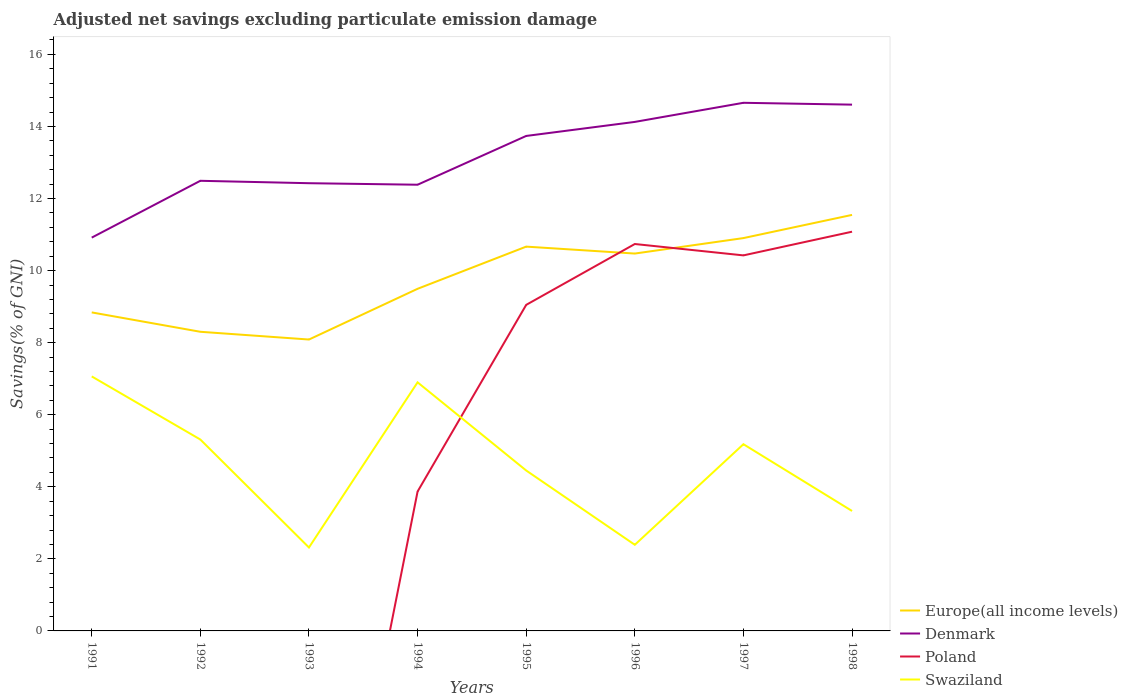Across all years, what is the maximum adjusted net savings in Denmark?
Provide a succinct answer. 10.92. What is the total adjusted net savings in Europe(all income levels) in the graph?
Offer a terse response. -1.19. What is the difference between the highest and the second highest adjusted net savings in Swaziland?
Give a very brief answer. 4.75. Is the adjusted net savings in Poland strictly greater than the adjusted net savings in Swaziland over the years?
Offer a terse response. No. How many years are there in the graph?
Provide a succinct answer. 8. Are the values on the major ticks of Y-axis written in scientific E-notation?
Provide a succinct answer. No. Does the graph contain any zero values?
Ensure brevity in your answer.  Yes. How many legend labels are there?
Offer a terse response. 4. How are the legend labels stacked?
Provide a short and direct response. Vertical. What is the title of the graph?
Give a very brief answer. Adjusted net savings excluding particulate emission damage. Does "Switzerland" appear as one of the legend labels in the graph?
Ensure brevity in your answer.  No. What is the label or title of the Y-axis?
Offer a terse response. Savings(% of GNI). What is the Savings(% of GNI) in Europe(all income levels) in 1991?
Your response must be concise. 8.84. What is the Savings(% of GNI) of Denmark in 1991?
Give a very brief answer. 10.92. What is the Savings(% of GNI) in Poland in 1991?
Your answer should be compact. 0. What is the Savings(% of GNI) in Swaziland in 1991?
Your answer should be very brief. 7.06. What is the Savings(% of GNI) of Europe(all income levels) in 1992?
Offer a very short reply. 8.3. What is the Savings(% of GNI) in Denmark in 1992?
Give a very brief answer. 12.49. What is the Savings(% of GNI) in Swaziland in 1992?
Offer a very short reply. 5.31. What is the Savings(% of GNI) of Europe(all income levels) in 1993?
Keep it short and to the point. 8.09. What is the Savings(% of GNI) of Denmark in 1993?
Your answer should be very brief. 12.43. What is the Savings(% of GNI) in Swaziland in 1993?
Your response must be concise. 2.32. What is the Savings(% of GNI) of Europe(all income levels) in 1994?
Offer a very short reply. 9.49. What is the Savings(% of GNI) of Denmark in 1994?
Your answer should be compact. 12.38. What is the Savings(% of GNI) in Poland in 1994?
Provide a short and direct response. 3.87. What is the Savings(% of GNI) of Swaziland in 1994?
Your answer should be very brief. 6.9. What is the Savings(% of GNI) of Europe(all income levels) in 1995?
Your response must be concise. 10.67. What is the Savings(% of GNI) of Denmark in 1995?
Provide a succinct answer. 13.74. What is the Savings(% of GNI) of Poland in 1995?
Your answer should be very brief. 9.05. What is the Savings(% of GNI) in Swaziland in 1995?
Make the answer very short. 4.45. What is the Savings(% of GNI) of Europe(all income levels) in 1996?
Your answer should be very brief. 10.47. What is the Savings(% of GNI) in Denmark in 1996?
Offer a very short reply. 14.13. What is the Savings(% of GNI) of Poland in 1996?
Ensure brevity in your answer.  10.74. What is the Savings(% of GNI) in Swaziland in 1996?
Offer a terse response. 2.39. What is the Savings(% of GNI) of Europe(all income levels) in 1997?
Provide a succinct answer. 10.9. What is the Savings(% of GNI) of Denmark in 1997?
Provide a short and direct response. 14.66. What is the Savings(% of GNI) in Poland in 1997?
Your answer should be very brief. 10.42. What is the Savings(% of GNI) of Swaziland in 1997?
Your answer should be compact. 5.18. What is the Savings(% of GNI) in Europe(all income levels) in 1998?
Ensure brevity in your answer.  11.55. What is the Savings(% of GNI) of Denmark in 1998?
Ensure brevity in your answer.  14.61. What is the Savings(% of GNI) in Poland in 1998?
Offer a very short reply. 11.08. What is the Savings(% of GNI) in Swaziland in 1998?
Provide a succinct answer. 3.33. Across all years, what is the maximum Savings(% of GNI) of Europe(all income levels)?
Give a very brief answer. 11.55. Across all years, what is the maximum Savings(% of GNI) in Denmark?
Offer a very short reply. 14.66. Across all years, what is the maximum Savings(% of GNI) of Poland?
Offer a terse response. 11.08. Across all years, what is the maximum Savings(% of GNI) of Swaziland?
Keep it short and to the point. 7.06. Across all years, what is the minimum Savings(% of GNI) in Europe(all income levels)?
Ensure brevity in your answer.  8.09. Across all years, what is the minimum Savings(% of GNI) of Denmark?
Offer a terse response. 10.92. Across all years, what is the minimum Savings(% of GNI) of Swaziland?
Provide a short and direct response. 2.32. What is the total Savings(% of GNI) in Europe(all income levels) in the graph?
Your answer should be very brief. 78.31. What is the total Savings(% of GNI) of Denmark in the graph?
Your answer should be compact. 105.34. What is the total Savings(% of GNI) of Poland in the graph?
Provide a short and direct response. 45.16. What is the total Savings(% of GNI) of Swaziland in the graph?
Provide a succinct answer. 36.94. What is the difference between the Savings(% of GNI) in Europe(all income levels) in 1991 and that in 1992?
Offer a very short reply. 0.54. What is the difference between the Savings(% of GNI) in Denmark in 1991 and that in 1992?
Offer a very short reply. -1.58. What is the difference between the Savings(% of GNI) of Swaziland in 1991 and that in 1992?
Make the answer very short. 1.75. What is the difference between the Savings(% of GNI) of Europe(all income levels) in 1991 and that in 1993?
Offer a very short reply. 0.75. What is the difference between the Savings(% of GNI) in Denmark in 1991 and that in 1993?
Your answer should be very brief. -1.51. What is the difference between the Savings(% of GNI) in Swaziland in 1991 and that in 1993?
Your answer should be very brief. 4.75. What is the difference between the Savings(% of GNI) of Europe(all income levels) in 1991 and that in 1994?
Your answer should be compact. -0.66. What is the difference between the Savings(% of GNI) of Denmark in 1991 and that in 1994?
Make the answer very short. -1.47. What is the difference between the Savings(% of GNI) of Swaziland in 1991 and that in 1994?
Provide a short and direct response. 0.16. What is the difference between the Savings(% of GNI) of Europe(all income levels) in 1991 and that in 1995?
Make the answer very short. -1.83. What is the difference between the Savings(% of GNI) in Denmark in 1991 and that in 1995?
Your answer should be compact. -2.82. What is the difference between the Savings(% of GNI) in Swaziland in 1991 and that in 1995?
Provide a short and direct response. 2.61. What is the difference between the Savings(% of GNI) in Europe(all income levels) in 1991 and that in 1996?
Offer a terse response. -1.63. What is the difference between the Savings(% of GNI) in Denmark in 1991 and that in 1996?
Your response must be concise. -3.21. What is the difference between the Savings(% of GNI) in Swaziland in 1991 and that in 1996?
Your response must be concise. 4.67. What is the difference between the Savings(% of GNI) in Europe(all income levels) in 1991 and that in 1997?
Make the answer very short. -2.06. What is the difference between the Savings(% of GNI) of Denmark in 1991 and that in 1997?
Keep it short and to the point. -3.74. What is the difference between the Savings(% of GNI) of Swaziland in 1991 and that in 1997?
Your response must be concise. 1.88. What is the difference between the Savings(% of GNI) of Europe(all income levels) in 1991 and that in 1998?
Provide a short and direct response. -2.71. What is the difference between the Savings(% of GNI) in Denmark in 1991 and that in 1998?
Offer a terse response. -3.69. What is the difference between the Savings(% of GNI) in Swaziland in 1991 and that in 1998?
Your response must be concise. 3.73. What is the difference between the Savings(% of GNI) in Europe(all income levels) in 1992 and that in 1993?
Offer a very short reply. 0.21. What is the difference between the Savings(% of GNI) in Denmark in 1992 and that in 1993?
Your response must be concise. 0.07. What is the difference between the Savings(% of GNI) in Swaziland in 1992 and that in 1993?
Your answer should be compact. 3. What is the difference between the Savings(% of GNI) in Europe(all income levels) in 1992 and that in 1994?
Offer a very short reply. -1.19. What is the difference between the Savings(% of GNI) of Denmark in 1992 and that in 1994?
Offer a very short reply. 0.11. What is the difference between the Savings(% of GNI) of Swaziland in 1992 and that in 1994?
Provide a succinct answer. -1.59. What is the difference between the Savings(% of GNI) in Europe(all income levels) in 1992 and that in 1995?
Give a very brief answer. -2.36. What is the difference between the Savings(% of GNI) in Denmark in 1992 and that in 1995?
Offer a terse response. -1.24. What is the difference between the Savings(% of GNI) in Swaziland in 1992 and that in 1995?
Offer a terse response. 0.86. What is the difference between the Savings(% of GNI) of Europe(all income levels) in 1992 and that in 1996?
Your response must be concise. -2.17. What is the difference between the Savings(% of GNI) in Denmark in 1992 and that in 1996?
Make the answer very short. -1.63. What is the difference between the Savings(% of GNI) in Swaziland in 1992 and that in 1996?
Make the answer very short. 2.92. What is the difference between the Savings(% of GNI) in Europe(all income levels) in 1992 and that in 1997?
Keep it short and to the point. -2.6. What is the difference between the Savings(% of GNI) in Denmark in 1992 and that in 1997?
Your answer should be compact. -2.16. What is the difference between the Savings(% of GNI) of Swaziland in 1992 and that in 1997?
Your response must be concise. 0.13. What is the difference between the Savings(% of GNI) of Europe(all income levels) in 1992 and that in 1998?
Offer a terse response. -3.24. What is the difference between the Savings(% of GNI) of Denmark in 1992 and that in 1998?
Give a very brief answer. -2.11. What is the difference between the Savings(% of GNI) in Swaziland in 1992 and that in 1998?
Offer a terse response. 1.98. What is the difference between the Savings(% of GNI) of Europe(all income levels) in 1993 and that in 1994?
Keep it short and to the point. -1.41. What is the difference between the Savings(% of GNI) of Denmark in 1993 and that in 1994?
Your answer should be compact. 0.04. What is the difference between the Savings(% of GNI) in Swaziland in 1993 and that in 1994?
Provide a succinct answer. -4.58. What is the difference between the Savings(% of GNI) in Europe(all income levels) in 1993 and that in 1995?
Your answer should be very brief. -2.58. What is the difference between the Savings(% of GNI) in Denmark in 1993 and that in 1995?
Your response must be concise. -1.31. What is the difference between the Savings(% of GNI) in Swaziland in 1993 and that in 1995?
Offer a terse response. -2.14. What is the difference between the Savings(% of GNI) in Europe(all income levels) in 1993 and that in 1996?
Offer a very short reply. -2.39. What is the difference between the Savings(% of GNI) of Denmark in 1993 and that in 1996?
Your answer should be very brief. -1.7. What is the difference between the Savings(% of GNI) in Swaziland in 1993 and that in 1996?
Ensure brevity in your answer.  -0.07. What is the difference between the Savings(% of GNI) in Europe(all income levels) in 1993 and that in 1997?
Ensure brevity in your answer.  -2.82. What is the difference between the Savings(% of GNI) in Denmark in 1993 and that in 1997?
Your answer should be very brief. -2.23. What is the difference between the Savings(% of GNI) of Swaziland in 1993 and that in 1997?
Give a very brief answer. -2.87. What is the difference between the Savings(% of GNI) in Europe(all income levels) in 1993 and that in 1998?
Give a very brief answer. -3.46. What is the difference between the Savings(% of GNI) in Denmark in 1993 and that in 1998?
Offer a terse response. -2.18. What is the difference between the Savings(% of GNI) of Swaziland in 1993 and that in 1998?
Your answer should be compact. -1.01. What is the difference between the Savings(% of GNI) in Europe(all income levels) in 1994 and that in 1995?
Your answer should be compact. -1.17. What is the difference between the Savings(% of GNI) of Denmark in 1994 and that in 1995?
Ensure brevity in your answer.  -1.35. What is the difference between the Savings(% of GNI) in Poland in 1994 and that in 1995?
Your response must be concise. -5.18. What is the difference between the Savings(% of GNI) of Swaziland in 1994 and that in 1995?
Ensure brevity in your answer.  2.45. What is the difference between the Savings(% of GNI) in Europe(all income levels) in 1994 and that in 1996?
Your answer should be very brief. -0.98. What is the difference between the Savings(% of GNI) of Denmark in 1994 and that in 1996?
Make the answer very short. -1.74. What is the difference between the Savings(% of GNI) of Poland in 1994 and that in 1996?
Your response must be concise. -6.87. What is the difference between the Savings(% of GNI) of Swaziland in 1994 and that in 1996?
Offer a very short reply. 4.51. What is the difference between the Savings(% of GNI) of Europe(all income levels) in 1994 and that in 1997?
Make the answer very short. -1.41. What is the difference between the Savings(% of GNI) of Denmark in 1994 and that in 1997?
Your answer should be very brief. -2.27. What is the difference between the Savings(% of GNI) in Poland in 1994 and that in 1997?
Give a very brief answer. -6.55. What is the difference between the Savings(% of GNI) of Swaziland in 1994 and that in 1997?
Provide a succinct answer. 1.72. What is the difference between the Savings(% of GNI) of Europe(all income levels) in 1994 and that in 1998?
Make the answer very short. -2.05. What is the difference between the Savings(% of GNI) of Denmark in 1994 and that in 1998?
Ensure brevity in your answer.  -2.22. What is the difference between the Savings(% of GNI) in Poland in 1994 and that in 1998?
Provide a short and direct response. -7.21. What is the difference between the Savings(% of GNI) of Swaziland in 1994 and that in 1998?
Make the answer very short. 3.57. What is the difference between the Savings(% of GNI) in Europe(all income levels) in 1995 and that in 1996?
Your response must be concise. 0.19. What is the difference between the Savings(% of GNI) in Denmark in 1995 and that in 1996?
Offer a very short reply. -0.39. What is the difference between the Savings(% of GNI) of Poland in 1995 and that in 1996?
Keep it short and to the point. -1.69. What is the difference between the Savings(% of GNI) in Swaziland in 1995 and that in 1996?
Ensure brevity in your answer.  2.06. What is the difference between the Savings(% of GNI) of Europe(all income levels) in 1995 and that in 1997?
Your answer should be compact. -0.24. What is the difference between the Savings(% of GNI) in Denmark in 1995 and that in 1997?
Ensure brevity in your answer.  -0.92. What is the difference between the Savings(% of GNI) in Poland in 1995 and that in 1997?
Provide a short and direct response. -1.37. What is the difference between the Savings(% of GNI) in Swaziland in 1995 and that in 1997?
Offer a terse response. -0.73. What is the difference between the Savings(% of GNI) of Europe(all income levels) in 1995 and that in 1998?
Offer a terse response. -0.88. What is the difference between the Savings(% of GNI) of Denmark in 1995 and that in 1998?
Ensure brevity in your answer.  -0.87. What is the difference between the Savings(% of GNI) of Poland in 1995 and that in 1998?
Offer a very short reply. -2.03. What is the difference between the Savings(% of GNI) in Swaziland in 1995 and that in 1998?
Ensure brevity in your answer.  1.12. What is the difference between the Savings(% of GNI) of Europe(all income levels) in 1996 and that in 1997?
Your answer should be compact. -0.43. What is the difference between the Savings(% of GNI) of Denmark in 1996 and that in 1997?
Your answer should be compact. -0.53. What is the difference between the Savings(% of GNI) in Poland in 1996 and that in 1997?
Provide a succinct answer. 0.32. What is the difference between the Savings(% of GNI) in Swaziland in 1996 and that in 1997?
Your answer should be very brief. -2.79. What is the difference between the Savings(% of GNI) of Europe(all income levels) in 1996 and that in 1998?
Your answer should be very brief. -1.07. What is the difference between the Savings(% of GNI) in Denmark in 1996 and that in 1998?
Keep it short and to the point. -0.48. What is the difference between the Savings(% of GNI) of Poland in 1996 and that in 1998?
Your answer should be compact. -0.34. What is the difference between the Savings(% of GNI) in Swaziland in 1996 and that in 1998?
Make the answer very short. -0.94. What is the difference between the Savings(% of GNI) in Europe(all income levels) in 1997 and that in 1998?
Offer a very short reply. -0.64. What is the difference between the Savings(% of GNI) of Denmark in 1997 and that in 1998?
Offer a very short reply. 0.05. What is the difference between the Savings(% of GNI) in Poland in 1997 and that in 1998?
Make the answer very short. -0.66. What is the difference between the Savings(% of GNI) of Swaziland in 1997 and that in 1998?
Your answer should be very brief. 1.85. What is the difference between the Savings(% of GNI) of Europe(all income levels) in 1991 and the Savings(% of GNI) of Denmark in 1992?
Make the answer very short. -3.65. What is the difference between the Savings(% of GNI) of Europe(all income levels) in 1991 and the Savings(% of GNI) of Swaziland in 1992?
Your answer should be very brief. 3.53. What is the difference between the Savings(% of GNI) in Denmark in 1991 and the Savings(% of GNI) in Swaziland in 1992?
Provide a succinct answer. 5.6. What is the difference between the Savings(% of GNI) of Europe(all income levels) in 1991 and the Savings(% of GNI) of Denmark in 1993?
Your answer should be very brief. -3.59. What is the difference between the Savings(% of GNI) of Europe(all income levels) in 1991 and the Savings(% of GNI) of Swaziland in 1993?
Offer a terse response. 6.52. What is the difference between the Savings(% of GNI) in Denmark in 1991 and the Savings(% of GNI) in Swaziland in 1993?
Provide a succinct answer. 8.6. What is the difference between the Savings(% of GNI) of Europe(all income levels) in 1991 and the Savings(% of GNI) of Denmark in 1994?
Provide a short and direct response. -3.54. What is the difference between the Savings(% of GNI) in Europe(all income levels) in 1991 and the Savings(% of GNI) in Poland in 1994?
Provide a succinct answer. 4.97. What is the difference between the Savings(% of GNI) in Europe(all income levels) in 1991 and the Savings(% of GNI) in Swaziland in 1994?
Ensure brevity in your answer.  1.94. What is the difference between the Savings(% of GNI) in Denmark in 1991 and the Savings(% of GNI) in Poland in 1994?
Keep it short and to the point. 7.05. What is the difference between the Savings(% of GNI) of Denmark in 1991 and the Savings(% of GNI) of Swaziland in 1994?
Ensure brevity in your answer.  4.02. What is the difference between the Savings(% of GNI) of Europe(all income levels) in 1991 and the Savings(% of GNI) of Denmark in 1995?
Provide a short and direct response. -4.9. What is the difference between the Savings(% of GNI) in Europe(all income levels) in 1991 and the Savings(% of GNI) in Poland in 1995?
Provide a short and direct response. -0.21. What is the difference between the Savings(% of GNI) of Europe(all income levels) in 1991 and the Savings(% of GNI) of Swaziland in 1995?
Your answer should be very brief. 4.39. What is the difference between the Savings(% of GNI) of Denmark in 1991 and the Savings(% of GNI) of Poland in 1995?
Give a very brief answer. 1.87. What is the difference between the Savings(% of GNI) in Denmark in 1991 and the Savings(% of GNI) in Swaziland in 1995?
Give a very brief answer. 6.46. What is the difference between the Savings(% of GNI) in Europe(all income levels) in 1991 and the Savings(% of GNI) in Denmark in 1996?
Provide a short and direct response. -5.29. What is the difference between the Savings(% of GNI) of Europe(all income levels) in 1991 and the Savings(% of GNI) of Poland in 1996?
Ensure brevity in your answer.  -1.9. What is the difference between the Savings(% of GNI) of Europe(all income levels) in 1991 and the Savings(% of GNI) of Swaziland in 1996?
Your answer should be very brief. 6.45. What is the difference between the Savings(% of GNI) of Denmark in 1991 and the Savings(% of GNI) of Poland in 1996?
Offer a very short reply. 0.18. What is the difference between the Savings(% of GNI) of Denmark in 1991 and the Savings(% of GNI) of Swaziland in 1996?
Your answer should be very brief. 8.52. What is the difference between the Savings(% of GNI) in Europe(all income levels) in 1991 and the Savings(% of GNI) in Denmark in 1997?
Ensure brevity in your answer.  -5.82. What is the difference between the Savings(% of GNI) of Europe(all income levels) in 1991 and the Savings(% of GNI) of Poland in 1997?
Make the answer very short. -1.58. What is the difference between the Savings(% of GNI) of Europe(all income levels) in 1991 and the Savings(% of GNI) of Swaziland in 1997?
Make the answer very short. 3.66. What is the difference between the Savings(% of GNI) in Denmark in 1991 and the Savings(% of GNI) in Poland in 1997?
Keep it short and to the point. 0.49. What is the difference between the Savings(% of GNI) of Denmark in 1991 and the Savings(% of GNI) of Swaziland in 1997?
Provide a succinct answer. 5.73. What is the difference between the Savings(% of GNI) of Europe(all income levels) in 1991 and the Savings(% of GNI) of Denmark in 1998?
Provide a succinct answer. -5.77. What is the difference between the Savings(% of GNI) of Europe(all income levels) in 1991 and the Savings(% of GNI) of Poland in 1998?
Your response must be concise. -2.24. What is the difference between the Savings(% of GNI) in Europe(all income levels) in 1991 and the Savings(% of GNI) in Swaziland in 1998?
Keep it short and to the point. 5.51. What is the difference between the Savings(% of GNI) of Denmark in 1991 and the Savings(% of GNI) of Poland in 1998?
Keep it short and to the point. -0.16. What is the difference between the Savings(% of GNI) in Denmark in 1991 and the Savings(% of GNI) in Swaziland in 1998?
Your answer should be compact. 7.59. What is the difference between the Savings(% of GNI) of Europe(all income levels) in 1992 and the Savings(% of GNI) of Denmark in 1993?
Keep it short and to the point. -4.12. What is the difference between the Savings(% of GNI) in Europe(all income levels) in 1992 and the Savings(% of GNI) in Swaziland in 1993?
Your response must be concise. 5.99. What is the difference between the Savings(% of GNI) of Denmark in 1992 and the Savings(% of GNI) of Swaziland in 1993?
Your response must be concise. 10.18. What is the difference between the Savings(% of GNI) in Europe(all income levels) in 1992 and the Savings(% of GNI) in Denmark in 1994?
Your answer should be very brief. -4.08. What is the difference between the Savings(% of GNI) in Europe(all income levels) in 1992 and the Savings(% of GNI) in Poland in 1994?
Your response must be concise. 4.43. What is the difference between the Savings(% of GNI) in Europe(all income levels) in 1992 and the Savings(% of GNI) in Swaziland in 1994?
Your response must be concise. 1.4. What is the difference between the Savings(% of GNI) of Denmark in 1992 and the Savings(% of GNI) of Poland in 1994?
Offer a terse response. 8.62. What is the difference between the Savings(% of GNI) in Denmark in 1992 and the Savings(% of GNI) in Swaziland in 1994?
Keep it short and to the point. 5.59. What is the difference between the Savings(% of GNI) in Europe(all income levels) in 1992 and the Savings(% of GNI) in Denmark in 1995?
Provide a succinct answer. -5.43. What is the difference between the Savings(% of GNI) of Europe(all income levels) in 1992 and the Savings(% of GNI) of Poland in 1995?
Provide a succinct answer. -0.75. What is the difference between the Savings(% of GNI) of Europe(all income levels) in 1992 and the Savings(% of GNI) of Swaziland in 1995?
Provide a succinct answer. 3.85. What is the difference between the Savings(% of GNI) of Denmark in 1992 and the Savings(% of GNI) of Poland in 1995?
Your answer should be compact. 3.44. What is the difference between the Savings(% of GNI) of Denmark in 1992 and the Savings(% of GNI) of Swaziland in 1995?
Make the answer very short. 8.04. What is the difference between the Savings(% of GNI) in Europe(all income levels) in 1992 and the Savings(% of GNI) in Denmark in 1996?
Provide a succinct answer. -5.82. What is the difference between the Savings(% of GNI) of Europe(all income levels) in 1992 and the Savings(% of GNI) of Poland in 1996?
Keep it short and to the point. -2.44. What is the difference between the Savings(% of GNI) in Europe(all income levels) in 1992 and the Savings(% of GNI) in Swaziland in 1996?
Ensure brevity in your answer.  5.91. What is the difference between the Savings(% of GNI) in Denmark in 1992 and the Savings(% of GNI) in Poland in 1996?
Your answer should be very brief. 1.75. What is the difference between the Savings(% of GNI) in Denmark in 1992 and the Savings(% of GNI) in Swaziland in 1996?
Provide a succinct answer. 10.1. What is the difference between the Savings(% of GNI) of Europe(all income levels) in 1992 and the Savings(% of GNI) of Denmark in 1997?
Give a very brief answer. -6.35. What is the difference between the Savings(% of GNI) in Europe(all income levels) in 1992 and the Savings(% of GNI) in Poland in 1997?
Your response must be concise. -2.12. What is the difference between the Savings(% of GNI) in Europe(all income levels) in 1992 and the Savings(% of GNI) in Swaziland in 1997?
Provide a succinct answer. 3.12. What is the difference between the Savings(% of GNI) of Denmark in 1992 and the Savings(% of GNI) of Poland in 1997?
Make the answer very short. 2.07. What is the difference between the Savings(% of GNI) in Denmark in 1992 and the Savings(% of GNI) in Swaziland in 1997?
Keep it short and to the point. 7.31. What is the difference between the Savings(% of GNI) of Europe(all income levels) in 1992 and the Savings(% of GNI) of Denmark in 1998?
Make the answer very short. -6.3. What is the difference between the Savings(% of GNI) in Europe(all income levels) in 1992 and the Savings(% of GNI) in Poland in 1998?
Your answer should be very brief. -2.78. What is the difference between the Savings(% of GNI) in Europe(all income levels) in 1992 and the Savings(% of GNI) in Swaziland in 1998?
Provide a short and direct response. 4.97. What is the difference between the Savings(% of GNI) of Denmark in 1992 and the Savings(% of GNI) of Poland in 1998?
Provide a succinct answer. 1.41. What is the difference between the Savings(% of GNI) in Denmark in 1992 and the Savings(% of GNI) in Swaziland in 1998?
Provide a succinct answer. 9.16. What is the difference between the Savings(% of GNI) in Europe(all income levels) in 1993 and the Savings(% of GNI) in Denmark in 1994?
Provide a short and direct response. -4.3. What is the difference between the Savings(% of GNI) of Europe(all income levels) in 1993 and the Savings(% of GNI) of Poland in 1994?
Provide a short and direct response. 4.22. What is the difference between the Savings(% of GNI) in Europe(all income levels) in 1993 and the Savings(% of GNI) in Swaziland in 1994?
Your answer should be compact. 1.19. What is the difference between the Savings(% of GNI) in Denmark in 1993 and the Savings(% of GNI) in Poland in 1994?
Provide a succinct answer. 8.56. What is the difference between the Savings(% of GNI) in Denmark in 1993 and the Savings(% of GNI) in Swaziland in 1994?
Give a very brief answer. 5.53. What is the difference between the Savings(% of GNI) of Europe(all income levels) in 1993 and the Savings(% of GNI) of Denmark in 1995?
Provide a short and direct response. -5.65. What is the difference between the Savings(% of GNI) of Europe(all income levels) in 1993 and the Savings(% of GNI) of Poland in 1995?
Offer a terse response. -0.96. What is the difference between the Savings(% of GNI) of Europe(all income levels) in 1993 and the Savings(% of GNI) of Swaziland in 1995?
Your answer should be very brief. 3.63. What is the difference between the Savings(% of GNI) in Denmark in 1993 and the Savings(% of GNI) in Poland in 1995?
Offer a terse response. 3.38. What is the difference between the Savings(% of GNI) of Denmark in 1993 and the Savings(% of GNI) of Swaziland in 1995?
Your answer should be very brief. 7.97. What is the difference between the Savings(% of GNI) in Europe(all income levels) in 1993 and the Savings(% of GNI) in Denmark in 1996?
Provide a short and direct response. -6.04. What is the difference between the Savings(% of GNI) in Europe(all income levels) in 1993 and the Savings(% of GNI) in Poland in 1996?
Offer a terse response. -2.65. What is the difference between the Savings(% of GNI) in Europe(all income levels) in 1993 and the Savings(% of GNI) in Swaziland in 1996?
Keep it short and to the point. 5.7. What is the difference between the Savings(% of GNI) in Denmark in 1993 and the Savings(% of GNI) in Poland in 1996?
Keep it short and to the point. 1.69. What is the difference between the Savings(% of GNI) in Denmark in 1993 and the Savings(% of GNI) in Swaziland in 1996?
Offer a terse response. 10.03. What is the difference between the Savings(% of GNI) of Europe(all income levels) in 1993 and the Savings(% of GNI) of Denmark in 1997?
Your answer should be very brief. -6.57. What is the difference between the Savings(% of GNI) in Europe(all income levels) in 1993 and the Savings(% of GNI) in Poland in 1997?
Your response must be concise. -2.34. What is the difference between the Savings(% of GNI) in Europe(all income levels) in 1993 and the Savings(% of GNI) in Swaziland in 1997?
Ensure brevity in your answer.  2.91. What is the difference between the Savings(% of GNI) of Denmark in 1993 and the Savings(% of GNI) of Poland in 1997?
Provide a short and direct response. 2. What is the difference between the Savings(% of GNI) of Denmark in 1993 and the Savings(% of GNI) of Swaziland in 1997?
Your answer should be very brief. 7.24. What is the difference between the Savings(% of GNI) in Europe(all income levels) in 1993 and the Savings(% of GNI) in Denmark in 1998?
Your answer should be very brief. -6.52. What is the difference between the Savings(% of GNI) of Europe(all income levels) in 1993 and the Savings(% of GNI) of Poland in 1998?
Your answer should be compact. -2.99. What is the difference between the Savings(% of GNI) of Europe(all income levels) in 1993 and the Savings(% of GNI) of Swaziland in 1998?
Make the answer very short. 4.76. What is the difference between the Savings(% of GNI) of Denmark in 1993 and the Savings(% of GNI) of Poland in 1998?
Give a very brief answer. 1.35. What is the difference between the Savings(% of GNI) of Denmark in 1993 and the Savings(% of GNI) of Swaziland in 1998?
Ensure brevity in your answer.  9.1. What is the difference between the Savings(% of GNI) in Europe(all income levels) in 1994 and the Savings(% of GNI) in Denmark in 1995?
Give a very brief answer. -4.24. What is the difference between the Savings(% of GNI) in Europe(all income levels) in 1994 and the Savings(% of GNI) in Poland in 1995?
Provide a succinct answer. 0.45. What is the difference between the Savings(% of GNI) of Europe(all income levels) in 1994 and the Savings(% of GNI) of Swaziland in 1995?
Provide a succinct answer. 5.04. What is the difference between the Savings(% of GNI) of Denmark in 1994 and the Savings(% of GNI) of Poland in 1995?
Give a very brief answer. 3.33. What is the difference between the Savings(% of GNI) in Denmark in 1994 and the Savings(% of GNI) in Swaziland in 1995?
Provide a succinct answer. 7.93. What is the difference between the Savings(% of GNI) of Poland in 1994 and the Savings(% of GNI) of Swaziland in 1995?
Provide a succinct answer. -0.58. What is the difference between the Savings(% of GNI) of Europe(all income levels) in 1994 and the Savings(% of GNI) of Denmark in 1996?
Keep it short and to the point. -4.63. What is the difference between the Savings(% of GNI) in Europe(all income levels) in 1994 and the Savings(% of GNI) in Poland in 1996?
Your answer should be very brief. -1.24. What is the difference between the Savings(% of GNI) of Europe(all income levels) in 1994 and the Savings(% of GNI) of Swaziland in 1996?
Offer a very short reply. 7.1. What is the difference between the Savings(% of GNI) in Denmark in 1994 and the Savings(% of GNI) in Poland in 1996?
Your answer should be very brief. 1.65. What is the difference between the Savings(% of GNI) of Denmark in 1994 and the Savings(% of GNI) of Swaziland in 1996?
Offer a terse response. 9.99. What is the difference between the Savings(% of GNI) of Poland in 1994 and the Savings(% of GNI) of Swaziland in 1996?
Ensure brevity in your answer.  1.48. What is the difference between the Savings(% of GNI) in Europe(all income levels) in 1994 and the Savings(% of GNI) in Denmark in 1997?
Give a very brief answer. -5.16. What is the difference between the Savings(% of GNI) in Europe(all income levels) in 1994 and the Savings(% of GNI) in Poland in 1997?
Your answer should be compact. -0.93. What is the difference between the Savings(% of GNI) in Europe(all income levels) in 1994 and the Savings(% of GNI) in Swaziland in 1997?
Keep it short and to the point. 4.31. What is the difference between the Savings(% of GNI) in Denmark in 1994 and the Savings(% of GNI) in Poland in 1997?
Offer a very short reply. 1.96. What is the difference between the Savings(% of GNI) of Denmark in 1994 and the Savings(% of GNI) of Swaziland in 1997?
Keep it short and to the point. 7.2. What is the difference between the Savings(% of GNI) in Poland in 1994 and the Savings(% of GNI) in Swaziland in 1997?
Your answer should be very brief. -1.31. What is the difference between the Savings(% of GNI) in Europe(all income levels) in 1994 and the Savings(% of GNI) in Denmark in 1998?
Ensure brevity in your answer.  -5.11. What is the difference between the Savings(% of GNI) in Europe(all income levels) in 1994 and the Savings(% of GNI) in Poland in 1998?
Give a very brief answer. -1.58. What is the difference between the Savings(% of GNI) of Europe(all income levels) in 1994 and the Savings(% of GNI) of Swaziland in 1998?
Offer a terse response. 6.17. What is the difference between the Savings(% of GNI) in Denmark in 1994 and the Savings(% of GNI) in Poland in 1998?
Provide a succinct answer. 1.3. What is the difference between the Savings(% of GNI) in Denmark in 1994 and the Savings(% of GNI) in Swaziland in 1998?
Offer a terse response. 9.05. What is the difference between the Savings(% of GNI) of Poland in 1994 and the Savings(% of GNI) of Swaziland in 1998?
Your answer should be very brief. 0.54. What is the difference between the Savings(% of GNI) of Europe(all income levels) in 1995 and the Savings(% of GNI) of Denmark in 1996?
Give a very brief answer. -3.46. What is the difference between the Savings(% of GNI) in Europe(all income levels) in 1995 and the Savings(% of GNI) in Poland in 1996?
Your answer should be compact. -0.07. What is the difference between the Savings(% of GNI) of Europe(all income levels) in 1995 and the Savings(% of GNI) of Swaziland in 1996?
Offer a terse response. 8.27. What is the difference between the Savings(% of GNI) of Denmark in 1995 and the Savings(% of GNI) of Poland in 1996?
Your response must be concise. 3. What is the difference between the Savings(% of GNI) of Denmark in 1995 and the Savings(% of GNI) of Swaziland in 1996?
Your response must be concise. 11.35. What is the difference between the Savings(% of GNI) in Poland in 1995 and the Savings(% of GNI) in Swaziland in 1996?
Offer a terse response. 6.66. What is the difference between the Savings(% of GNI) of Europe(all income levels) in 1995 and the Savings(% of GNI) of Denmark in 1997?
Provide a succinct answer. -3.99. What is the difference between the Savings(% of GNI) in Europe(all income levels) in 1995 and the Savings(% of GNI) in Poland in 1997?
Provide a short and direct response. 0.24. What is the difference between the Savings(% of GNI) in Europe(all income levels) in 1995 and the Savings(% of GNI) in Swaziland in 1997?
Ensure brevity in your answer.  5.48. What is the difference between the Savings(% of GNI) in Denmark in 1995 and the Savings(% of GNI) in Poland in 1997?
Your answer should be compact. 3.31. What is the difference between the Savings(% of GNI) of Denmark in 1995 and the Savings(% of GNI) of Swaziland in 1997?
Provide a short and direct response. 8.56. What is the difference between the Savings(% of GNI) in Poland in 1995 and the Savings(% of GNI) in Swaziland in 1997?
Offer a terse response. 3.87. What is the difference between the Savings(% of GNI) in Europe(all income levels) in 1995 and the Savings(% of GNI) in Denmark in 1998?
Provide a short and direct response. -3.94. What is the difference between the Savings(% of GNI) of Europe(all income levels) in 1995 and the Savings(% of GNI) of Poland in 1998?
Provide a short and direct response. -0.41. What is the difference between the Savings(% of GNI) in Europe(all income levels) in 1995 and the Savings(% of GNI) in Swaziland in 1998?
Your answer should be compact. 7.34. What is the difference between the Savings(% of GNI) of Denmark in 1995 and the Savings(% of GNI) of Poland in 1998?
Your answer should be compact. 2.66. What is the difference between the Savings(% of GNI) in Denmark in 1995 and the Savings(% of GNI) in Swaziland in 1998?
Offer a very short reply. 10.41. What is the difference between the Savings(% of GNI) of Poland in 1995 and the Savings(% of GNI) of Swaziland in 1998?
Provide a succinct answer. 5.72. What is the difference between the Savings(% of GNI) of Europe(all income levels) in 1996 and the Savings(% of GNI) of Denmark in 1997?
Give a very brief answer. -4.18. What is the difference between the Savings(% of GNI) of Europe(all income levels) in 1996 and the Savings(% of GNI) of Poland in 1997?
Offer a terse response. 0.05. What is the difference between the Savings(% of GNI) of Europe(all income levels) in 1996 and the Savings(% of GNI) of Swaziland in 1997?
Offer a terse response. 5.29. What is the difference between the Savings(% of GNI) in Denmark in 1996 and the Savings(% of GNI) in Poland in 1997?
Offer a terse response. 3.7. What is the difference between the Savings(% of GNI) in Denmark in 1996 and the Savings(% of GNI) in Swaziland in 1997?
Ensure brevity in your answer.  8.94. What is the difference between the Savings(% of GNI) of Poland in 1996 and the Savings(% of GNI) of Swaziland in 1997?
Keep it short and to the point. 5.56. What is the difference between the Savings(% of GNI) of Europe(all income levels) in 1996 and the Savings(% of GNI) of Denmark in 1998?
Your response must be concise. -4.13. What is the difference between the Savings(% of GNI) in Europe(all income levels) in 1996 and the Savings(% of GNI) in Poland in 1998?
Make the answer very short. -0.61. What is the difference between the Savings(% of GNI) in Europe(all income levels) in 1996 and the Savings(% of GNI) in Swaziland in 1998?
Offer a very short reply. 7.14. What is the difference between the Savings(% of GNI) in Denmark in 1996 and the Savings(% of GNI) in Poland in 1998?
Keep it short and to the point. 3.05. What is the difference between the Savings(% of GNI) of Denmark in 1996 and the Savings(% of GNI) of Swaziland in 1998?
Your answer should be compact. 10.8. What is the difference between the Savings(% of GNI) of Poland in 1996 and the Savings(% of GNI) of Swaziland in 1998?
Ensure brevity in your answer.  7.41. What is the difference between the Savings(% of GNI) of Europe(all income levels) in 1997 and the Savings(% of GNI) of Denmark in 1998?
Provide a short and direct response. -3.7. What is the difference between the Savings(% of GNI) in Europe(all income levels) in 1997 and the Savings(% of GNI) in Poland in 1998?
Offer a very short reply. -0.18. What is the difference between the Savings(% of GNI) in Europe(all income levels) in 1997 and the Savings(% of GNI) in Swaziland in 1998?
Make the answer very short. 7.57. What is the difference between the Savings(% of GNI) in Denmark in 1997 and the Savings(% of GNI) in Poland in 1998?
Give a very brief answer. 3.58. What is the difference between the Savings(% of GNI) in Denmark in 1997 and the Savings(% of GNI) in Swaziland in 1998?
Offer a terse response. 11.33. What is the difference between the Savings(% of GNI) in Poland in 1997 and the Savings(% of GNI) in Swaziland in 1998?
Offer a terse response. 7.09. What is the average Savings(% of GNI) in Europe(all income levels) per year?
Make the answer very short. 9.79. What is the average Savings(% of GNI) in Denmark per year?
Your response must be concise. 13.17. What is the average Savings(% of GNI) of Poland per year?
Ensure brevity in your answer.  5.64. What is the average Savings(% of GNI) in Swaziland per year?
Keep it short and to the point. 4.62. In the year 1991, what is the difference between the Savings(% of GNI) in Europe(all income levels) and Savings(% of GNI) in Denmark?
Offer a terse response. -2.08. In the year 1991, what is the difference between the Savings(% of GNI) in Europe(all income levels) and Savings(% of GNI) in Swaziland?
Give a very brief answer. 1.78. In the year 1991, what is the difference between the Savings(% of GNI) of Denmark and Savings(% of GNI) of Swaziland?
Your response must be concise. 3.85. In the year 1992, what is the difference between the Savings(% of GNI) in Europe(all income levels) and Savings(% of GNI) in Denmark?
Offer a terse response. -4.19. In the year 1992, what is the difference between the Savings(% of GNI) of Europe(all income levels) and Savings(% of GNI) of Swaziland?
Your response must be concise. 2.99. In the year 1992, what is the difference between the Savings(% of GNI) in Denmark and Savings(% of GNI) in Swaziland?
Provide a short and direct response. 7.18. In the year 1993, what is the difference between the Savings(% of GNI) of Europe(all income levels) and Savings(% of GNI) of Denmark?
Provide a succinct answer. -4.34. In the year 1993, what is the difference between the Savings(% of GNI) in Europe(all income levels) and Savings(% of GNI) in Swaziland?
Your response must be concise. 5.77. In the year 1993, what is the difference between the Savings(% of GNI) in Denmark and Savings(% of GNI) in Swaziland?
Provide a short and direct response. 10.11. In the year 1994, what is the difference between the Savings(% of GNI) in Europe(all income levels) and Savings(% of GNI) in Denmark?
Your answer should be very brief. -2.89. In the year 1994, what is the difference between the Savings(% of GNI) in Europe(all income levels) and Savings(% of GNI) in Poland?
Make the answer very short. 5.63. In the year 1994, what is the difference between the Savings(% of GNI) in Europe(all income levels) and Savings(% of GNI) in Swaziland?
Make the answer very short. 2.6. In the year 1994, what is the difference between the Savings(% of GNI) of Denmark and Savings(% of GNI) of Poland?
Offer a very short reply. 8.51. In the year 1994, what is the difference between the Savings(% of GNI) in Denmark and Savings(% of GNI) in Swaziland?
Provide a short and direct response. 5.48. In the year 1994, what is the difference between the Savings(% of GNI) in Poland and Savings(% of GNI) in Swaziland?
Keep it short and to the point. -3.03. In the year 1995, what is the difference between the Savings(% of GNI) in Europe(all income levels) and Savings(% of GNI) in Denmark?
Give a very brief answer. -3.07. In the year 1995, what is the difference between the Savings(% of GNI) of Europe(all income levels) and Savings(% of GNI) of Poland?
Provide a short and direct response. 1.62. In the year 1995, what is the difference between the Savings(% of GNI) of Europe(all income levels) and Savings(% of GNI) of Swaziland?
Your response must be concise. 6.21. In the year 1995, what is the difference between the Savings(% of GNI) of Denmark and Savings(% of GNI) of Poland?
Make the answer very short. 4.69. In the year 1995, what is the difference between the Savings(% of GNI) of Denmark and Savings(% of GNI) of Swaziland?
Offer a terse response. 9.28. In the year 1995, what is the difference between the Savings(% of GNI) in Poland and Savings(% of GNI) in Swaziland?
Your answer should be compact. 4.6. In the year 1996, what is the difference between the Savings(% of GNI) of Europe(all income levels) and Savings(% of GNI) of Denmark?
Give a very brief answer. -3.65. In the year 1996, what is the difference between the Savings(% of GNI) of Europe(all income levels) and Savings(% of GNI) of Poland?
Provide a succinct answer. -0.26. In the year 1996, what is the difference between the Savings(% of GNI) of Europe(all income levels) and Savings(% of GNI) of Swaziland?
Offer a very short reply. 8.08. In the year 1996, what is the difference between the Savings(% of GNI) in Denmark and Savings(% of GNI) in Poland?
Make the answer very short. 3.39. In the year 1996, what is the difference between the Savings(% of GNI) of Denmark and Savings(% of GNI) of Swaziland?
Your answer should be compact. 11.74. In the year 1996, what is the difference between the Savings(% of GNI) in Poland and Savings(% of GNI) in Swaziland?
Offer a terse response. 8.35. In the year 1997, what is the difference between the Savings(% of GNI) in Europe(all income levels) and Savings(% of GNI) in Denmark?
Your answer should be compact. -3.75. In the year 1997, what is the difference between the Savings(% of GNI) of Europe(all income levels) and Savings(% of GNI) of Poland?
Provide a succinct answer. 0.48. In the year 1997, what is the difference between the Savings(% of GNI) in Europe(all income levels) and Savings(% of GNI) in Swaziland?
Ensure brevity in your answer.  5.72. In the year 1997, what is the difference between the Savings(% of GNI) in Denmark and Savings(% of GNI) in Poland?
Your answer should be very brief. 4.23. In the year 1997, what is the difference between the Savings(% of GNI) of Denmark and Savings(% of GNI) of Swaziland?
Give a very brief answer. 9.47. In the year 1997, what is the difference between the Savings(% of GNI) of Poland and Savings(% of GNI) of Swaziland?
Your answer should be very brief. 5.24. In the year 1998, what is the difference between the Savings(% of GNI) of Europe(all income levels) and Savings(% of GNI) of Denmark?
Your answer should be compact. -3.06. In the year 1998, what is the difference between the Savings(% of GNI) in Europe(all income levels) and Savings(% of GNI) in Poland?
Give a very brief answer. 0.47. In the year 1998, what is the difference between the Savings(% of GNI) in Europe(all income levels) and Savings(% of GNI) in Swaziland?
Keep it short and to the point. 8.22. In the year 1998, what is the difference between the Savings(% of GNI) of Denmark and Savings(% of GNI) of Poland?
Offer a very short reply. 3.53. In the year 1998, what is the difference between the Savings(% of GNI) in Denmark and Savings(% of GNI) in Swaziland?
Ensure brevity in your answer.  11.28. In the year 1998, what is the difference between the Savings(% of GNI) of Poland and Savings(% of GNI) of Swaziland?
Give a very brief answer. 7.75. What is the ratio of the Savings(% of GNI) of Europe(all income levels) in 1991 to that in 1992?
Provide a succinct answer. 1.06. What is the ratio of the Savings(% of GNI) in Denmark in 1991 to that in 1992?
Provide a short and direct response. 0.87. What is the ratio of the Savings(% of GNI) in Swaziland in 1991 to that in 1992?
Provide a short and direct response. 1.33. What is the ratio of the Savings(% of GNI) of Europe(all income levels) in 1991 to that in 1993?
Your answer should be very brief. 1.09. What is the ratio of the Savings(% of GNI) in Denmark in 1991 to that in 1993?
Keep it short and to the point. 0.88. What is the ratio of the Savings(% of GNI) of Swaziland in 1991 to that in 1993?
Your answer should be very brief. 3.05. What is the ratio of the Savings(% of GNI) of Denmark in 1991 to that in 1994?
Provide a succinct answer. 0.88. What is the ratio of the Savings(% of GNI) in Swaziland in 1991 to that in 1994?
Make the answer very short. 1.02. What is the ratio of the Savings(% of GNI) of Europe(all income levels) in 1991 to that in 1995?
Your response must be concise. 0.83. What is the ratio of the Savings(% of GNI) of Denmark in 1991 to that in 1995?
Offer a very short reply. 0.79. What is the ratio of the Savings(% of GNI) of Swaziland in 1991 to that in 1995?
Make the answer very short. 1.59. What is the ratio of the Savings(% of GNI) in Europe(all income levels) in 1991 to that in 1996?
Provide a succinct answer. 0.84. What is the ratio of the Savings(% of GNI) in Denmark in 1991 to that in 1996?
Give a very brief answer. 0.77. What is the ratio of the Savings(% of GNI) in Swaziland in 1991 to that in 1996?
Make the answer very short. 2.95. What is the ratio of the Savings(% of GNI) in Europe(all income levels) in 1991 to that in 1997?
Provide a succinct answer. 0.81. What is the ratio of the Savings(% of GNI) in Denmark in 1991 to that in 1997?
Give a very brief answer. 0.74. What is the ratio of the Savings(% of GNI) in Swaziland in 1991 to that in 1997?
Provide a succinct answer. 1.36. What is the ratio of the Savings(% of GNI) of Europe(all income levels) in 1991 to that in 1998?
Offer a terse response. 0.77. What is the ratio of the Savings(% of GNI) in Denmark in 1991 to that in 1998?
Keep it short and to the point. 0.75. What is the ratio of the Savings(% of GNI) of Swaziland in 1991 to that in 1998?
Provide a succinct answer. 2.12. What is the ratio of the Savings(% of GNI) of Europe(all income levels) in 1992 to that in 1993?
Ensure brevity in your answer.  1.03. What is the ratio of the Savings(% of GNI) in Denmark in 1992 to that in 1993?
Your answer should be compact. 1.01. What is the ratio of the Savings(% of GNI) in Swaziland in 1992 to that in 1993?
Your answer should be very brief. 2.29. What is the ratio of the Savings(% of GNI) in Europe(all income levels) in 1992 to that in 1994?
Your answer should be very brief. 0.87. What is the ratio of the Savings(% of GNI) in Denmark in 1992 to that in 1994?
Offer a terse response. 1.01. What is the ratio of the Savings(% of GNI) of Swaziland in 1992 to that in 1994?
Offer a very short reply. 0.77. What is the ratio of the Savings(% of GNI) of Europe(all income levels) in 1992 to that in 1995?
Offer a very short reply. 0.78. What is the ratio of the Savings(% of GNI) in Denmark in 1992 to that in 1995?
Your answer should be very brief. 0.91. What is the ratio of the Savings(% of GNI) in Swaziland in 1992 to that in 1995?
Provide a succinct answer. 1.19. What is the ratio of the Savings(% of GNI) of Europe(all income levels) in 1992 to that in 1996?
Your answer should be compact. 0.79. What is the ratio of the Savings(% of GNI) of Denmark in 1992 to that in 1996?
Provide a succinct answer. 0.88. What is the ratio of the Savings(% of GNI) of Swaziland in 1992 to that in 1996?
Give a very brief answer. 2.22. What is the ratio of the Savings(% of GNI) in Europe(all income levels) in 1992 to that in 1997?
Provide a succinct answer. 0.76. What is the ratio of the Savings(% of GNI) in Denmark in 1992 to that in 1997?
Ensure brevity in your answer.  0.85. What is the ratio of the Savings(% of GNI) in Swaziland in 1992 to that in 1997?
Your response must be concise. 1.03. What is the ratio of the Savings(% of GNI) of Europe(all income levels) in 1992 to that in 1998?
Give a very brief answer. 0.72. What is the ratio of the Savings(% of GNI) of Denmark in 1992 to that in 1998?
Offer a terse response. 0.86. What is the ratio of the Savings(% of GNI) in Swaziland in 1992 to that in 1998?
Provide a short and direct response. 1.6. What is the ratio of the Savings(% of GNI) in Europe(all income levels) in 1993 to that in 1994?
Keep it short and to the point. 0.85. What is the ratio of the Savings(% of GNI) of Denmark in 1993 to that in 1994?
Your answer should be very brief. 1. What is the ratio of the Savings(% of GNI) of Swaziland in 1993 to that in 1994?
Give a very brief answer. 0.34. What is the ratio of the Savings(% of GNI) in Europe(all income levels) in 1993 to that in 1995?
Ensure brevity in your answer.  0.76. What is the ratio of the Savings(% of GNI) of Denmark in 1993 to that in 1995?
Make the answer very short. 0.9. What is the ratio of the Savings(% of GNI) of Swaziland in 1993 to that in 1995?
Your response must be concise. 0.52. What is the ratio of the Savings(% of GNI) in Europe(all income levels) in 1993 to that in 1996?
Your answer should be compact. 0.77. What is the ratio of the Savings(% of GNI) in Denmark in 1993 to that in 1996?
Keep it short and to the point. 0.88. What is the ratio of the Savings(% of GNI) in Swaziland in 1993 to that in 1996?
Give a very brief answer. 0.97. What is the ratio of the Savings(% of GNI) in Europe(all income levels) in 1993 to that in 1997?
Ensure brevity in your answer.  0.74. What is the ratio of the Savings(% of GNI) of Denmark in 1993 to that in 1997?
Provide a short and direct response. 0.85. What is the ratio of the Savings(% of GNI) in Swaziland in 1993 to that in 1997?
Your response must be concise. 0.45. What is the ratio of the Savings(% of GNI) in Europe(all income levels) in 1993 to that in 1998?
Give a very brief answer. 0.7. What is the ratio of the Savings(% of GNI) of Denmark in 1993 to that in 1998?
Offer a very short reply. 0.85. What is the ratio of the Savings(% of GNI) in Swaziland in 1993 to that in 1998?
Your answer should be compact. 0.7. What is the ratio of the Savings(% of GNI) of Europe(all income levels) in 1994 to that in 1995?
Provide a short and direct response. 0.89. What is the ratio of the Savings(% of GNI) of Denmark in 1994 to that in 1995?
Your answer should be very brief. 0.9. What is the ratio of the Savings(% of GNI) of Poland in 1994 to that in 1995?
Offer a very short reply. 0.43. What is the ratio of the Savings(% of GNI) of Swaziland in 1994 to that in 1995?
Provide a succinct answer. 1.55. What is the ratio of the Savings(% of GNI) in Europe(all income levels) in 1994 to that in 1996?
Keep it short and to the point. 0.91. What is the ratio of the Savings(% of GNI) in Denmark in 1994 to that in 1996?
Ensure brevity in your answer.  0.88. What is the ratio of the Savings(% of GNI) of Poland in 1994 to that in 1996?
Give a very brief answer. 0.36. What is the ratio of the Savings(% of GNI) in Swaziland in 1994 to that in 1996?
Ensure brevity in your answer.  2.89. What is the ratio of the Savings(% of GNI) in Europe(all income levels) in 1994 to that in 1997?
Provide a succinct answer. 0.87. What is the ratio of the Savings(% of GNI) in Denmark in 1994 to that in 1997?
Offer a terse response. 0.84. What is the ratio of the Savings(% of GNI) of Poland in 1994 to that in 1997?
Give a very brief answer. 0.37. What is the ratio of the Savings(% of GNI) in Swaziland in 1994 to that in 1997?
Give a very brief answer. 1.33. What is the ratio of the Savings(% of GNI) of Europe(all income levels) in 1994 to that in 1998?
Your response must be concise. 0.82. What is the ratio of the Savings(% of GNI) of Denmark in 1994 to that in 1998?
Ensure brevity in your answer.  0.85. What is the ratio of the Savings(% of GNI) in Poland in 1994 to that in 1998?
Provide a succinct answer. 0.35. What is the ratio of the Savings(% of GNI) of Swaziland in 1994 to that in 1998?
Your answer should be very brief. 2.07. What is the ratio of the Savings(% of GNI) of Europe(all income levels) in 1995 to that in 1996?
Provide a succinct answer. 1.02. What is the ratio of the Savings(% of GNI) in Denmark in 1995 to that in 1996?
Make the answer very short. 0.97. What is the ratio of the Savings(% of GNI) in Poland in 1995 to that in 1996?
Give a very brief answer. 0.84. What is the ratio of the Savings(% of GNI) of Swaziland in 1995 to that in 1996?
Ensure brevity in your answer.  1.86. What is the ratio of the Savings(% of GNI) of Europe(all income levels) in 1995 to that in 1997?
Offer a terse response. 0.98. What is the ratio of the Savings(% of GNI) in Denmark in 1995 to that in 1997?
Ensure brevity in your answer.  0.94. What is the ratio of the Savings(% of GNI) in Poland in 1995 to that in 1997?
Ensure brevity in your answer.  0.87. What is the ratio of the Savings(% of GNI) in Swaziland in 1995 to that in 1997?
Your response must be concise. 0.86. What is the ratio of the Savings(% of GNI) in Europe(all income levels) in 1995 to that in 1998?
Provide a succinct answer. 0.92. What is the ratio of the Savings(% of GNI) in Denmark in 1995 to that in 1998?
Provide a short and direct response. 0.94. What is the ratio of the Savings(% of GNI) in Poland in 1995 to that in 1998?
Provide a succinct answer. 0.82. What is the ratio of the Savings(% of GNI) of Swaziland in 1995 to that in 1998?
Offer a terse response. 1.34. What is the ratio of the Savings(% of GNI) in Europe(all income levels) in 1996 to that in 1997?
Ensure brevity in your answer.  0.96. What is the ratio of the Savings(% of GNI) in Denmark in 1996 to that in 1997?
Provide a succinct answer. 0.96. What is the ratio of the Savings(% of GNI) of Poland in 1996 to that in 1997?
Provide a succinct answer. 1.03. What is the ratio of the Savings(% of GNI) in Swaziland in 1996 to that in 1997?
Provide a short and direct response. 0.46. What is the ratio of the Savings(% of GNI) of Europe(all income levels) in 1996 to that in 1998?
Your response must be concise. 0.91. What is the ratio of the Savings(% of GNI) of Denmark in 1996 to that in 1998?
Your answer should be compact. 0.97. What is the ratio of the Savings(% of GNI) in Poland in 1996 to that in 1998?
Your response must be concise. 0.97. What is the ratio of the Savings(% of GNI) of Swaziland in 1996 to that in 1998?
Ensure brevity in your answer.  0.72. What is the ratio of the Savings(% of GNI) in Europe(all income levels) in 1997 to that in 1998?
Offer a very short reply. 0.94. What is the ratio of the Savings(% of GNI) of Denmark in 1997 to that in 1998?
Your answer should be compact. 1. What is the ratio of the Savings(% of GNI) in Poland in 1997 to that in 1998?
Your answer should be compact. 0.94. What is the ratio of the Savings(% of GNI) in Swaziland in 1997 to that in 1998?
Ensure brevity in your answer.  1.56. What is the difference between the highest and the second highest Savings(% of GNI) of Europe(all income levels)?
Offer a terse response. 0.64. What is the difference between the highest and the second highest Savings(% of GNI) of Denmark?
Offer a very short reply. 0.05. What is the difference between the highest and the second highest Savings(% of GNI) of Poland?
Make the answer very short. 0.34. What is the difference between the highest and the second highest Savings(% of GNI) of Swaziland?
Your response must be concise. 0.16. What is the difference between the highest and the lowest Savings(% of GNI) of Europe(all income levels)?
Give a very brief answer. 3.46. What is the difference between the highest and the lowest Savings(% of GNI) of Denmark?
Your response must be concise. 3.74. What is the difference between the highest and the lowest Savings(% of GNI) of Poland?
Provide a short and direct response. 11.08. What is the difference between the highest and the lowest Savings(% of GNI) of Swaziland?
Ensure brevity in your answer.  4.75. 